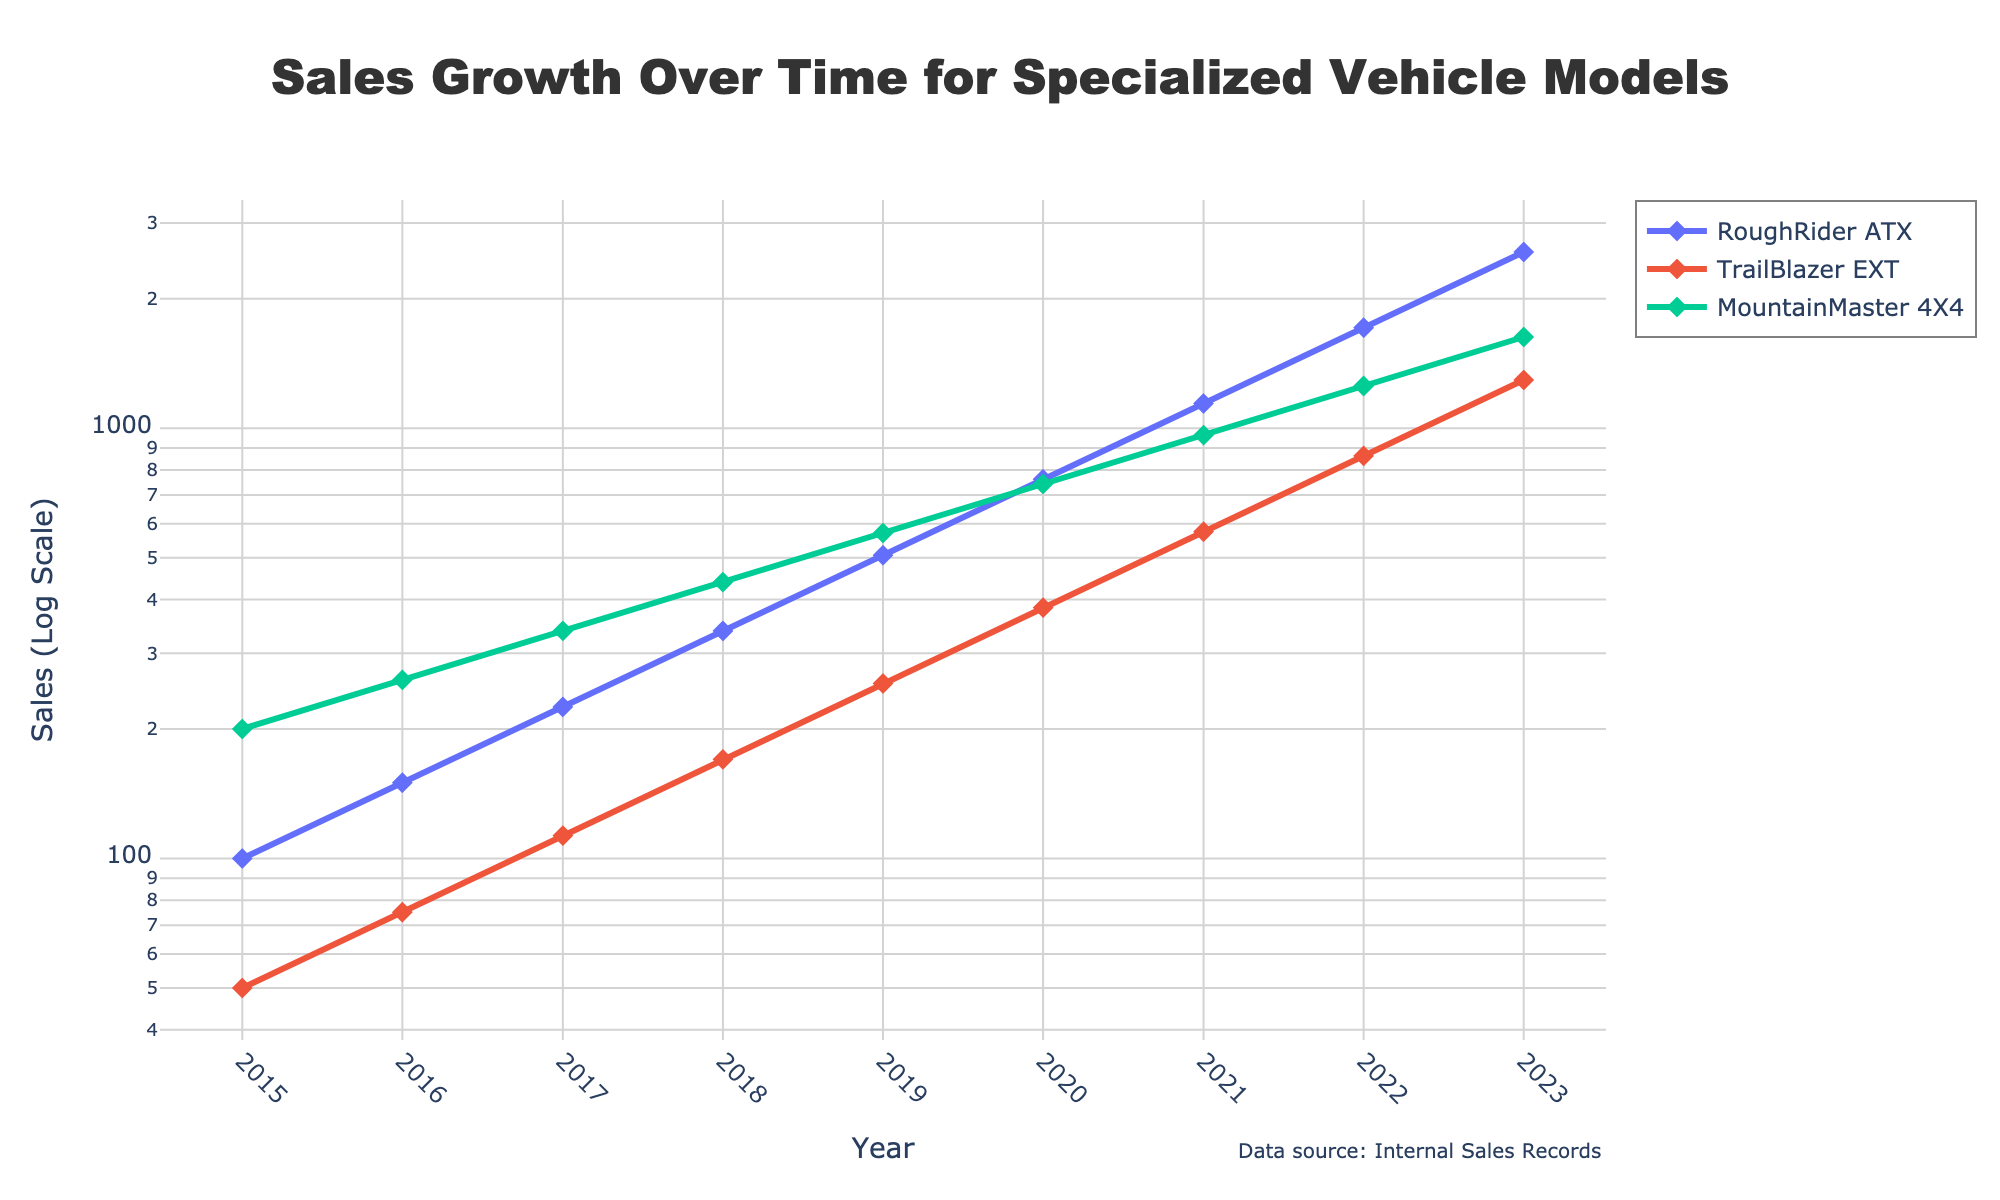What is the title of the plot? Look at the top of the figure where the title is located. This plot is titled "Sales Growth Over Time for Specialized Vehicle Models".
Answer: Sales Growth Over Time for Specialized Vehicle Models Which model shows the highest sales in 2023? Check the data points for the year 2023 and compare the sales values for each model. The RoughRider ATX has the highest sales in 2023.
Answer: RoughRider ATX What is the value of sales for the TrailBlazer EXT in 2019? Locate the year 2019 on the x-axis and find the corresponding sales value for the TrailBlazer EXT.
Answer: 255 units How did the sales for MountainMaster 4X4 change from 2020 to 2023? Identify the sales values for MountainMaster 4X4 in both 2020 and 2023, then calculate the percentage change using the formula (final value - initial value) / initial value * 100. The sales increased from 742 in 2020 to 1630 in 2023, which is a %=((1630-742)/742)*100 ≈ 119.7% increase.
Answer: Increased by approximately 119.7% What model exhibited the steadiest growth over the years? Observe the sales curves of each model and identify which model’s curve shows the least fluctuation and the smoothest increase. It appears that MountainMaster 4X4 has the steadiest growth.
Answer: MountainMaster 4X4 How does the sales growth of RoughRider ATX in 2017 compare to TrailBlazer EXT? Compare the sales values for both RoughRider ATX and TrailBlazer EXT in the year 2017. RoughRider ATX had 225 units, while the TrailBlazer EXT had 113 units.
Answer: RoughRider ATX had higher sales What is the average sales increase per year for the RoughRider ATX between 2015 and 2023? Calculate the total increase in sales for RoughRider ATX from 2015 to 2023 (2569-100=2469 units) and divide by the number of years (2023-2015=8 years). The average increase per year is 2469 units / 8 years.
Answer: 308.625 units/year Which year experienced the largest single-year sales increase for any model? Examine each year-to-year change for all models and identify the largest increase. RoughRider ATX's sales increased from 1142 units in 2021 to 1713 units in 2022, which is the largest single-year increase of 571 units.
Answer: 2022 for RoughRider ATX, 571 units How does the log scale help visualize the sales data? A log scale helps to better visualize data spanning several orders of magnitude by compressing the scale for higher values and expanding it for lower values, making it easier to discern growth trends over time.
Answer: It better visualizes growth trends over a wide range 